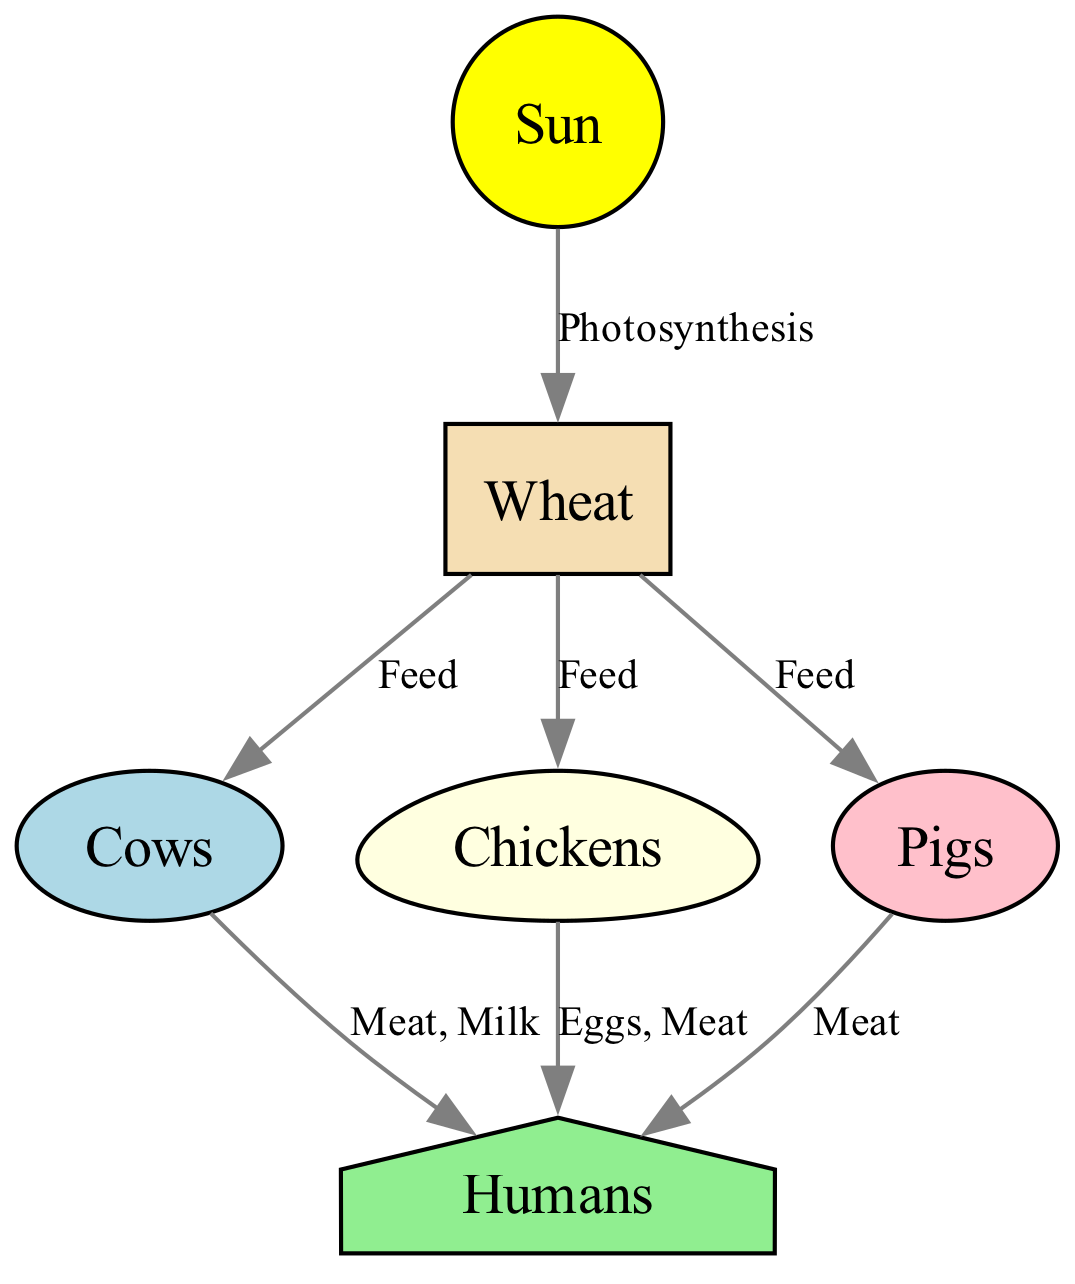What is the primary energy source in this food chain? The diagram indicates that the "Sun" is the starting point, as it is the source of energy for photosynthesis, which produces wheat. Therefore, the primary energy source is the "Sun."
Answer: Sun How many animals are directly fed by wheat? The diagram shows three animals (Cows, Chickens, Pigs) that receive nourishment from wheat. By directly looking at the connections from the wheat node, we can see it feeds all three. Therefore, the total is three animals.
Answer: 3 What do cows provide to humans? The diagram states that cows provide "Meat, Milk" to humans, indicating the types of foods humans obtain from cows. Thus, the answer is the goods provided, which are meat and milk.
Answer: Meat, Milk Which animal is not a direct food source for humans? Analyzing the diagram, the connection shows that humans get food directly from cows, chickens, and pigs, but chickens are not mentioned in the context of direct consumption. Therefore, chickens do not provide humans with food in the same way as the others involved in this chain.
Answer: Chickens How many edges are in the food chain? Counting the arrows in the diagram, we find there are a total of seven edges that connect various nodes. Each represents a relationship whereby one organism provides a resource to another. Therefore, the count of edges is seven.
Answer: 7 Which node is the final recipient of food in the chain? The diagram indicates that "humans" is the last node connected by edges. It receives direct contributions from cows, chickens, and pigs, so the final recipient of food is "humans."
Answer: Humans What role does wheat play in this food chain? Examining the flow from the sun to wheat and further to animals, we understand that wheat functions as a producer that validates the energy flow from the sun to different animals. Thus, it plays a role as a feeding resource for multiple animals.
Answer: Feed 